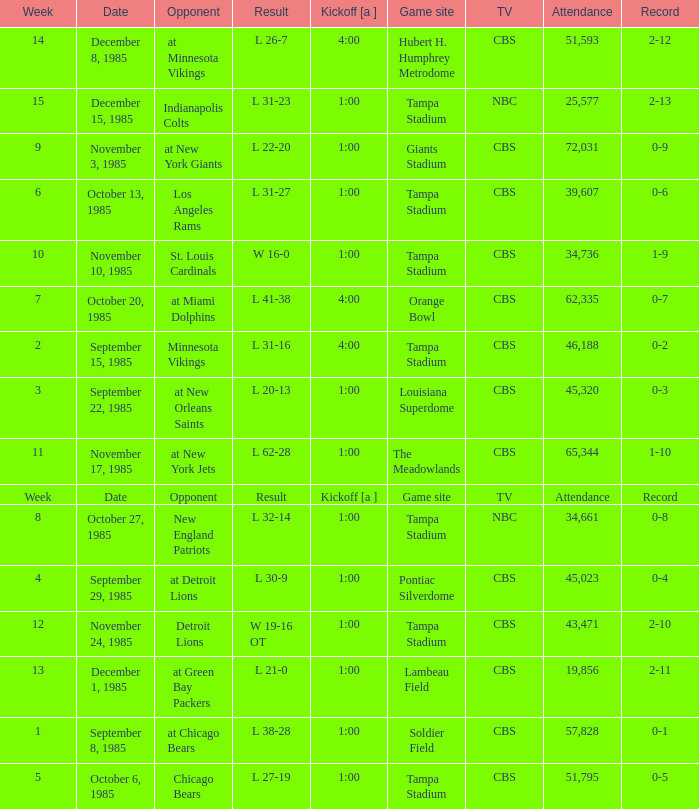Help me parse the entirety of this table. {'header': ['Week', 'Date', 'Opponent', 'Result', 'Kickoff [a ]', 'Game site', 'TV', 'Attendance', 'Record'], 'rows': [['14', 'December 8, 1985', 'at Minnesota Vikings', 'L 26-7', '4:00', 'Hubert H. Humphrey Metrodome', 'CBS', '51,593', '2-12'], ['15', 'December 15, 1985', 'Indianapolis Colts', 'L 31-23', '1:00', 'Tampa Stadium', 'NBC', '25,577', '2-13'], ['9', 'November 3, 1985', 'at New York Giants', 'L 22-20', '1:00', 'Giants Stadium', 'CBS', '72,031', '0-9'], ['6', 'October 13, 1985', 'Los Angeles Rams', 'L 31-27', '1:00', 'Tampa Stadium', 'CBS', '39,607', '0-6'], ['10', 'November 10, 1985', 'St. Louis Cardinals', 'W 16-0', '1:00', 'Tampa Stadium', 'CBS', '34,736', '1-9'], ['7', 'October 20, 1985', 'at Miami Dolphins', 'L 41-38', '4:00', 'Orange Bowl', 'CBS', '62,335', '0-7'], ['2', 'September 15, 1985', 'Minnesota Vikings', 'L 31-16', '4:00', 'Tampa Stadium', 'CBS', '46,188', '0-2'], ['3', 'September 22, 1985', 'at New Orleans Saints', 'L 20-13', '1:00', 'Louisiana Superdome', 'CBS', '45,320', '0-3'], ['11', 'November 17, 1985', 'at New York Jets', 'L 62-28', '1:00', 'The Meadowlands', 'CBS', '65,344', '1-10'], ['Week', 'Date', 'Opponent', 'Result', 'Kickoff [a ]', 'Game site', 'TV', 'Attendance', 'Record'], ['8', 'October 27, 1985', 'New England Patriots', 'L 32-14', '1:00', 'Tampa Stadium', 'NBC', '34,661', '0-8'], ['4', 'September 29, 1985', 'at Detroit Lions', 'L 30-9', '1:00', 'Pontiac Silverdome', 'CBS', '45,023', '0-4'], ['12', 'November 24, 1985', 'Detroit Lions', 'W 19-16 OT', '1:00', 'Tampa Stadium', 'CBS', '43,471', '2-10'], ['13', 'December 1, 1985', 'at Green Bay Packers', 'L 21-0', '1:00', 'Lambeau Field', 'CBS', '19,856', '2-11'], ['1', 'September 8, 1985', 'at Chicago Bears', 'L 38-28', '1:00', 'Soldier Field', 'CBS', '57,828', '0-1'], ['5', 'October 6, 1985', 'Chicago Bears', 'L 27-19', '1:00', 'Tampa Stadium', 'CBS', '51,795', '0-5']]} Find all the result(s) with the record of 2-13. L 31-23. 